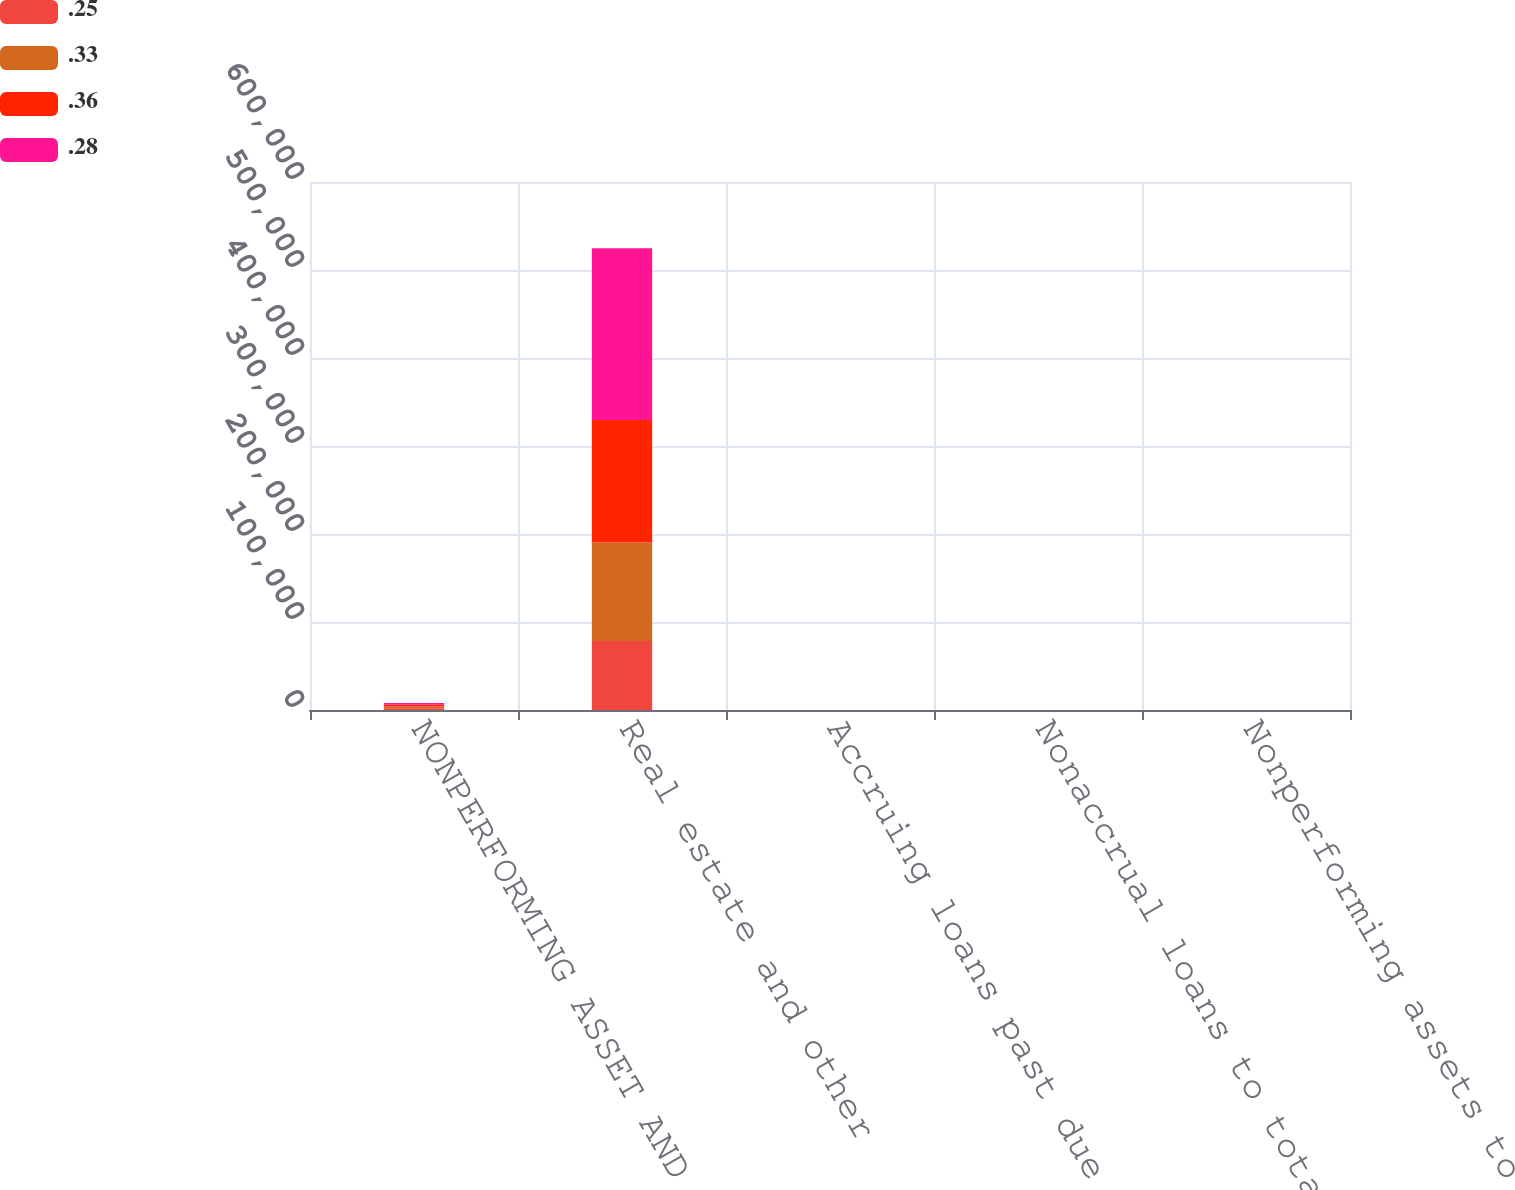Convert chart. <chart><loc_0><loc_0><loc_500><loc_500><stacked_bar_chart><ecel><fcel>NONPERFORMING ASSET AND PAST<fcel>Real estate and other<fcel>Accruing loans past due 90<fcel>Nonaccrual loans to total<fcel>Nonperforming assets to total<nl><fcel>0.25<fcel>2018<fcel>78375<fcel>0.25<fcel>1.01<fcel>1.1<nl><fcel>0.33<fcel>2017<fcel>111910<fcel>0.28<fcel>1<fcel>1.13<nl><fcel>0.36<fcel>2016<fcel>139206<fcel>0.33<fcel>1.01<fcel>1.16<nl><fcel>0.28<fcel>2015<fcel>195085<fcel>0.36<fcel>0.91<fcel>1.13<nl></chart> 